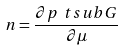Convert formula to latex. <formula><loc_0><loc_0><loc_500><loc_500>n = \frac { \partial p \ t s u b { G } } { \partial \mu }</formula> 